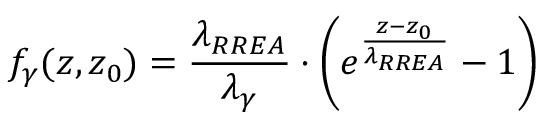Convert formula to latex. <formula><loc_0><loc_0><loc_500><loc_500>f _ { \gamma } ( z , z _ { 0 } ) = \frac { \lambda _ { R R E A } } { \lambda _ { \gamma } } \cdot \left ( e ^ { \frac { z - z _ { 0 } } { \lambda _ { R R E A } } } - 1 \right )</formula> 